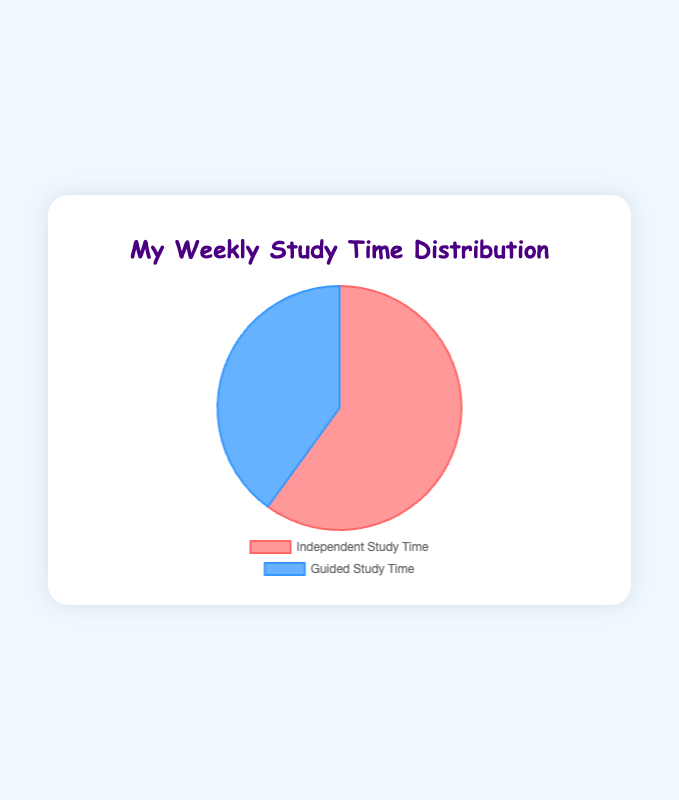What is the total number of study hours per week? Add the hours of Independent Study Time (18 hours) and Guided Study Time (12 hours) together: 18 + 12 = 30 hours
Answer: 30 hours Which type of study time takes more hours per week? Compare the hours for Independent Study Time (18 hours) and Guided Study Time (12 hours). Since 18 is greater than 12, Independent Study Time takes more hours.
Answer: Independent Study Time What percentage of the total study time is Guided Study Time? Calculate the fraction of Guided Study Time (12 hours) over the total study time (30 hours), then convert to a percentage: (12/30) * 100 = 40%
Answer: 40% By how many hours does Independent Study Time exceed Guided Study Time? Subtract the hours of Guided Study Time from Independent Study Time: 18 - 12 = 6 hours
Answer: 6 hours What is the average number of study hours per type per week? Add both study times (18 hours + 12 hours) to get 30 hours, then divide by 2 types: 30 / 2 = 15 hours
Answer: 15 hours What is the ratio of Independent Study Time to Guided Study Time? Divide the hours of Independent Study Time by the hours of Guided Study Time: 18 / 12. Simplify the fraction: 3 / 2 or 1.5 to 1
Answer: 1.5 to 1 Which segment has the larger area in the pie chart? The segment representing Independent Study Time, as it has 18 hours compared to Guided Study Time's 12 hours
Answer: Independent Study Time How much more would Guided Study Time need to be to be equal to Independent Study Time? Calculate the difference between Independent Study Time and Guided Study Time: 18 - 12 = 6 hours
Answer: 6 hours What colors are used to represent Independent Study Time and Guided Study Time? The pie chart uses a distinct color for each type: Independent Study Time is represented by a light red/pinkish color, and Guided Study Time is represented by a light blue color
Answer: Light red/pinkish and light blue 